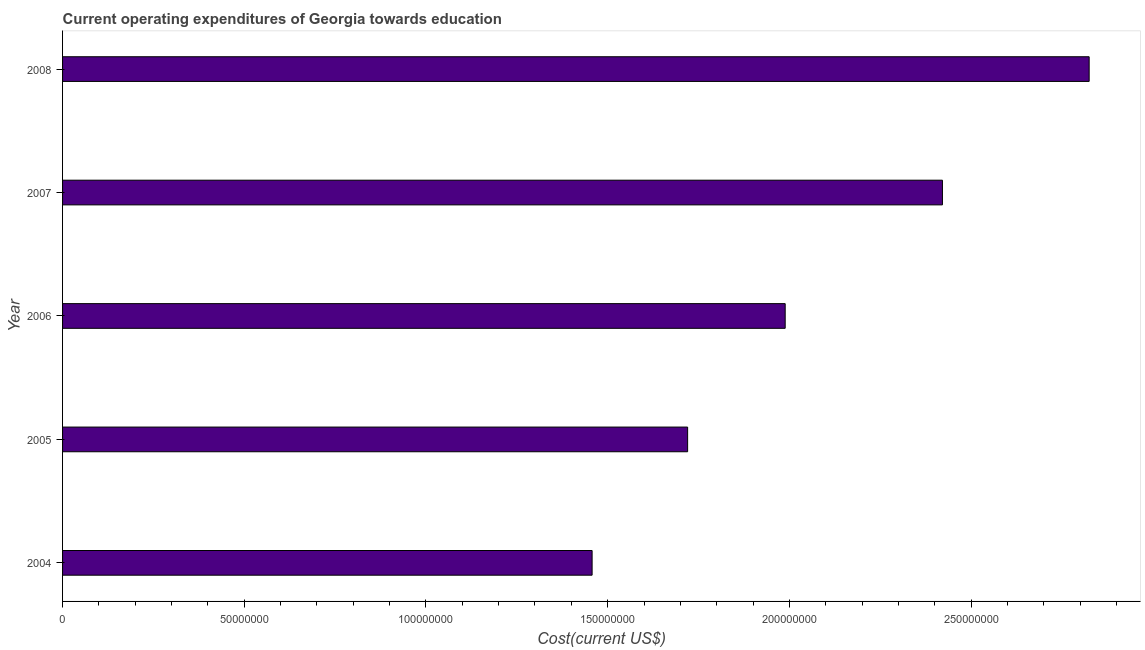What is the title of the graph?
Your response must be concise. Current operating expenditures of Georgia towards education. What is the label or title of the X-axis?
Offer a very short reply. Cost(current US$). What is the education expenditure in 2004?
Make the answer very short. 1.46e+08. Across all years, what is the maximum education expenditure?
Provide a short and direct response. 2.82e+08. Across all years, what is the minimum education expenditure?
Your response must be concise. 1.46e+08. What is the sum of the education expenditure?
Provide a succinct answer. 1.04e+09. What is the difference between the education expenditure in 2007 and 2008?
Ensure brevity in your answer.  -4.04e+07. What is the average education expenditure per year?
Give a very brief answer. 2.08e+08. What is the median education expenditure?
Provide a short and direct response. 1.99e+08. What is the ratio of the education expenditure in 2004 to that in 2008?
Your answer should be very brief. 0.52. What is the difference between the highest and the second highest education expenditure?
Provide a succinct answer. 4.04e+07. What is the difference between the highest and the lowest education expenditure?
Your answer should be compact. 1.37e+08. How many bars are there?
Offer a very short reply. 5. Are all the bars in the graph horizontal?
Provide a succinct answer. Yes. How many years are there in the graph?
Your answer should be very brief. 5. What is the Cost(current US$) of 2004?
Provide a short and direct response. 1.46e+08. What is the Cost(current US$) in 2005?
Make the answer very short. 1.72e+08. What is the Cost(current US$) in 2006?
Provide a short and direct response. 1.99e+08. What is the Cost(current US$) of 2007?
Provide a short and direct response. 2.42e+08. What is the Cost(current US$) of 2008?
Your answer should be compact. 2.82e+08. What is the difference between the Cost(current US$) in 2004 and 2005?
Your answer should be very brief. -2.63e+07. What is the difference between the Cost(current US$) in 2004 and 2006?
Your answer should be compact. -5.31e+07. What is the difference between the Cost(current US$) in 2004 and 2007?
Ensure brevity in your answer.  -9.64e+07. What is the difference between the Cost(current US$) in 2004 and 2008?
Give a very brief answer. -1.37e+08. What is the difference between the Cost(current US$) in 2005 and 2006?
Keep it short and to the point. -2.68e+07. What is the difference between the Cost(current US$) in 2005 and 2007?
Offer a terse response. -7.01e+07. What is the difference between the Cost(current US$) in 2005 and 2008?
Ensure brevity in your answer.  -1.10e+08. What is the difference between the Cost(current US$) in 2006 and 2007?
Your answer should be compact. -4.33e+07. What is the difference between the Cost(current US$) in 2006 and 2008?
Ensure brevity in your answer.  -8.36e+07. What is the difference between the Cost(current US$) in 2007 and 2008?
Keep it short and to the point. -4.04e+07. What is the ratio of the Cost(current US$) in 2004 to that in 2005?
Ensure brevity in your answer.  0.85. What is the ratio of the Cost(current US$) in 2004 to that in 2006?
Give a very brief answer. 0.73. What is the ratio of the Cost(current US$) in 2004 to that in 2007?
Keep it short and to the point. 0.6. What is the ratio of the Cost(current US$) in 2004 to that in 2008?
Provide a succinct answer. 0.52. What is the ratio of the Cost(current US$) in 2005 to that in 2006?
Keep it short and to the point. 0.86. What is the ratio of the Cost(current US$) in 2005 to that in 2007?
Offer a terse response. 0.71. What is the ratio of the Cost(current US$) in 2005 to that in 2008?
Provide a short and direct response. 0.61. What is the ratio of the Cost(current US$) in 2006 to that in 2007?
Provide a succinct answer. 0.82. What is the ratio of the Cost(current US$) in 2006 to that in 2008?
Your answer should be very brief. 0.7. What is the ratio of the Cost(current US$) in 2007 to that in 2008?
Keep it short and to the point. 0.86. 